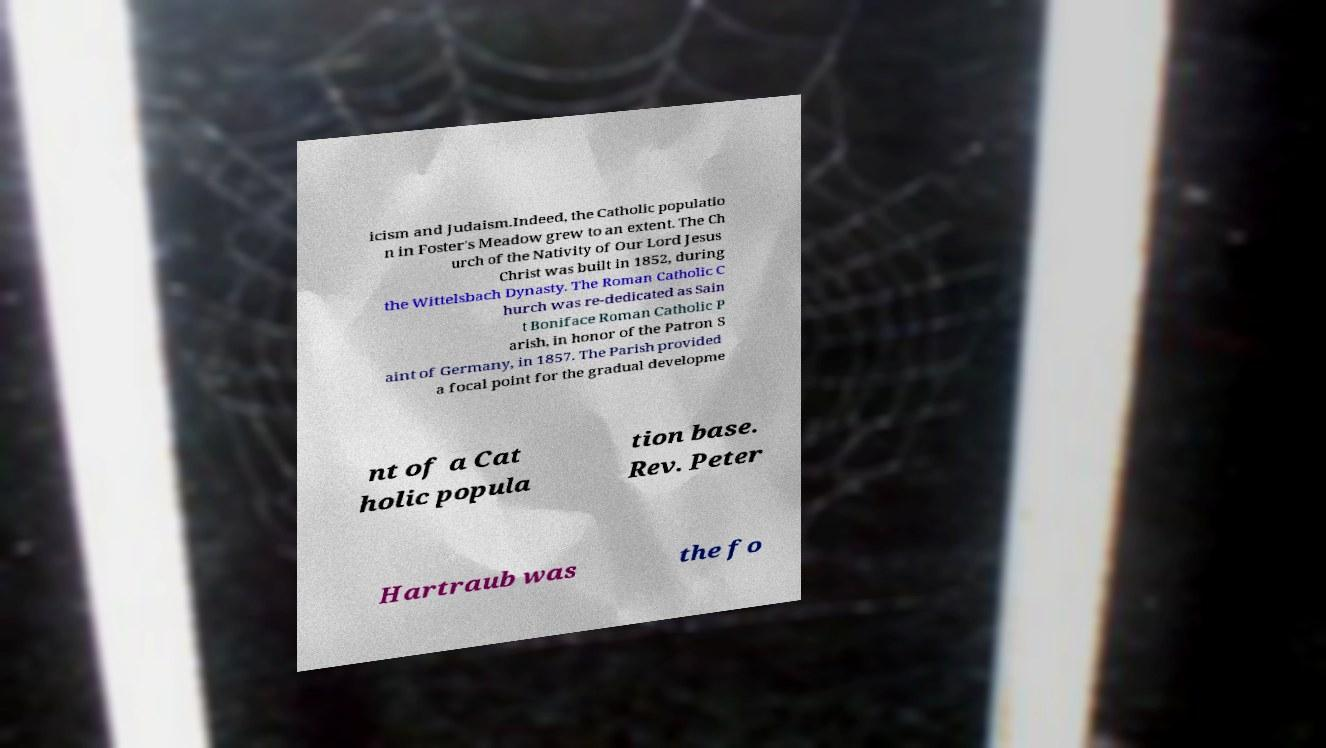Can you read and provide the text displayed in the image?This photo seems to have some interesting text. Can you extract and type it out for me? icism and Judaism.Indeed, the Catholic populatio n in Foster's Meadow grew to an extent. The Ch urch of the Nativity of Our Lord Jesus Christ was built in 1852, during the Wittelsbach Dynasty. The Roman Catholic C hurch was re-dedicated as Sain t Boniface Roman Catholic P arish, in honor of the Patron S aint of Germany, in 1857. The Parish provided a focal point for the gradual developme nt of a Cat holic popula tion base. Rev. Peter Hartraub was the fo 